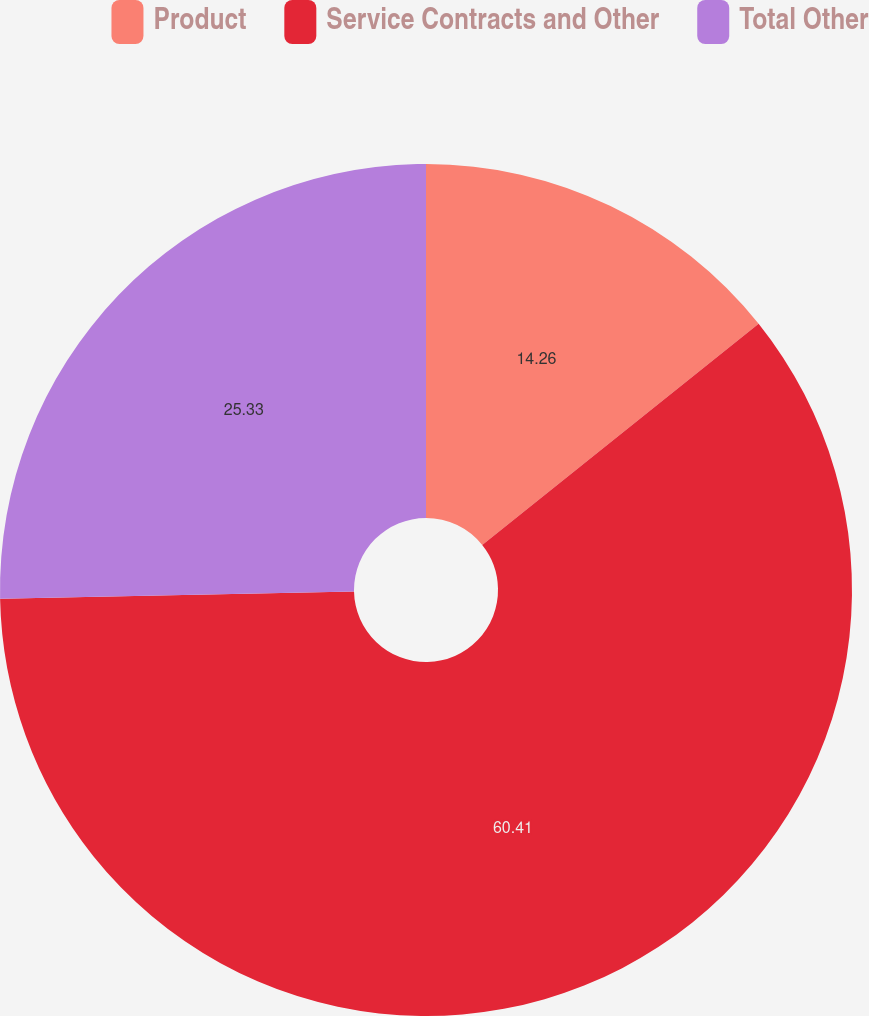Convert chart to OTSL. <chart><loc_0><loc_0><loc_500><loc_500><pie_chart><fcel>Product<fcel>Service Contracts and Other<fcel>Total Other<nl><fcel>14.26%<fcel>60.41%<fcel>25.33%<nl></chart> 